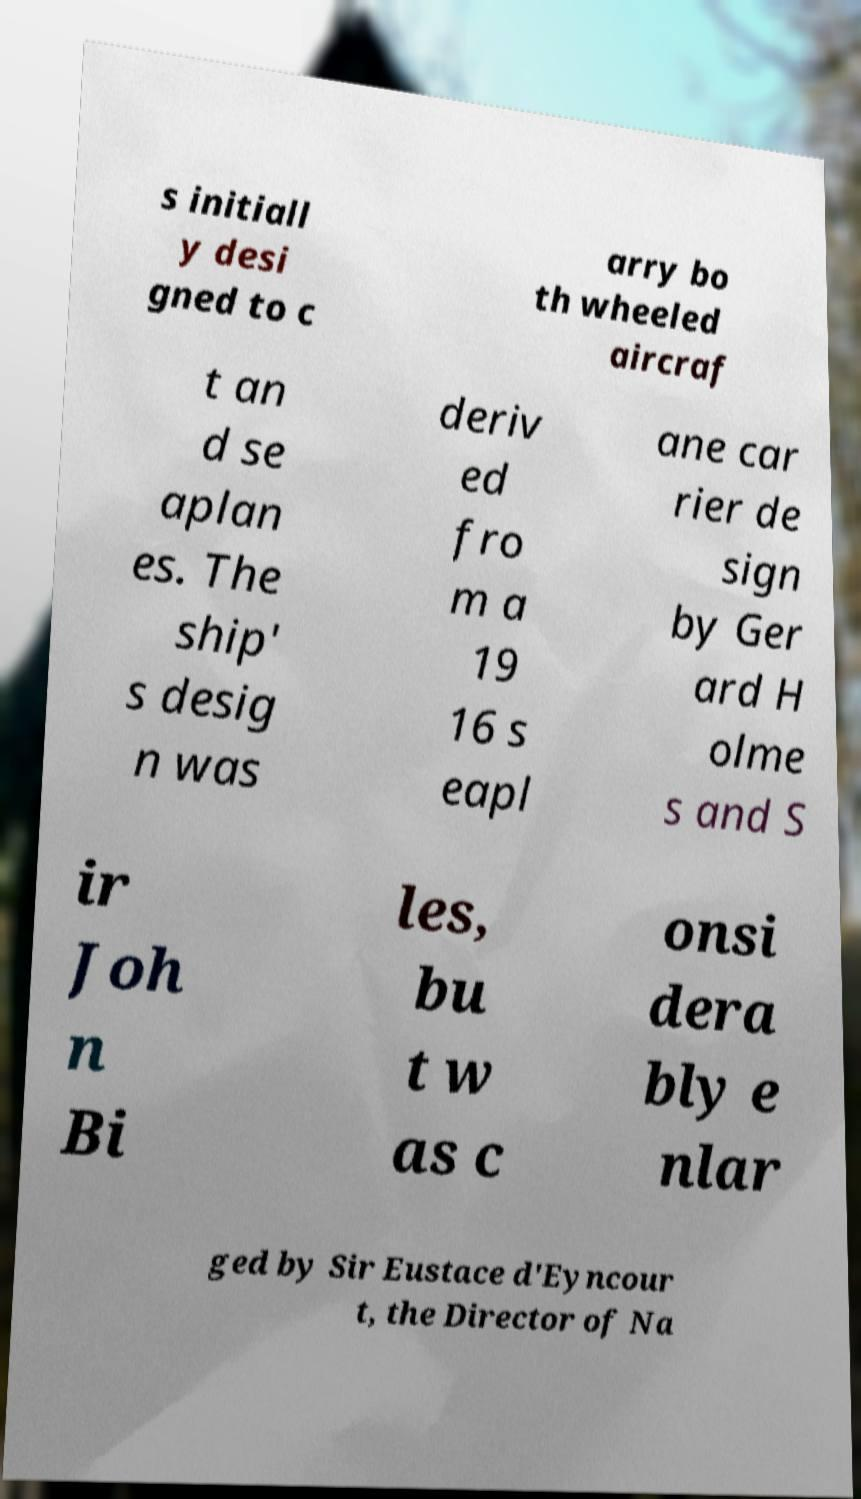Can you accurately transcribe the text from the provided image for me? s initiall y desi gned to c arry bo th wheeled aircraf t an d se aplan es. The ship' s desig n was deriv ed fro m a 19 16 s eapl ane car rier de sign by Ger ard H olme s and S ir Joh n Bi les, bu t w as c onsi dera bly e nlar ged by Sir Eustace d'Eyncour t, the Director of Na 